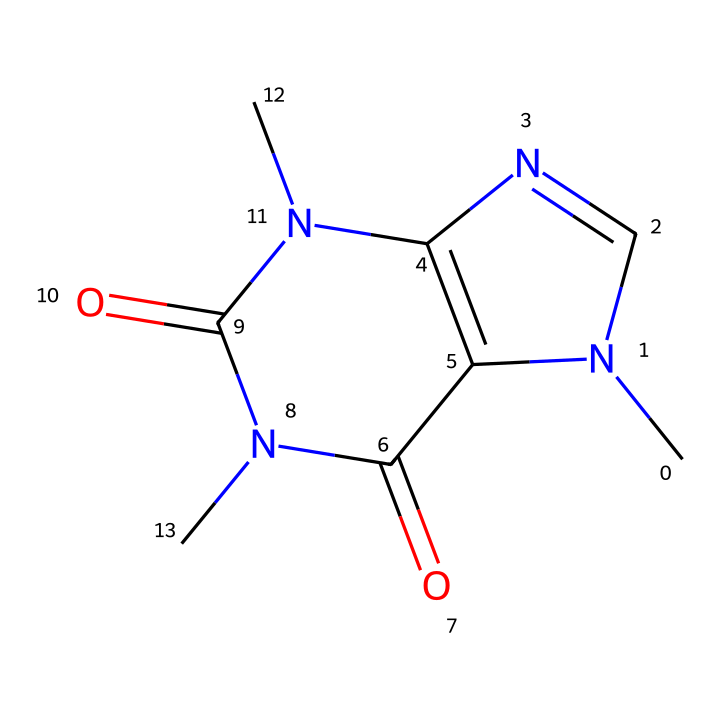how many nitrogen atoms are in the structure? By examining the SMILES representation, we locate the 'N' characters, which stand for nitrogen atoms. The representation features three 'N' atoms within its structure.
Answer: three what is the molecular formula of caffeine? The molecular formula can be deduced by counting the elements represented in the SMILES. The structure indicates the presence of carbon (C), hydrogen (H), nitrogen (N), and oxygen (O), resulting in the formula C8H10N4O2.
Answer: C8H10N4O2 how many rings are present in the molecular structure? Rings are identified by any cyclic structures in the SMILES representation. The given structure contains two fused rings, as indicated by the ring closure symbols (for example, 'N1' and 'N2').
Answer: two what type of drug is caffeine classified as? Caffeine is classified as a stimulant due to its action on the central nervous system, often enhancing alertness and energy levels. This classification is derived from its physiological effects as indicated by its structural characteristics.
Answer: stimulant does caffeine have any functional groups? In the provided SMILES, caffeine contains functional groups, notably amine groups (indicated by nitrogen atoms) and carbonyl groups (represented by 'C=O'). These groups play crucial roles in its chemical behavior and interactions.
Answer: yes what is the primary effect of caffeine on the human body? Caffeine primarily acts as a central nervous system stimulant, increasing alertness and reducing fatigue. This effect is fundamentally tied to its structural properties and the way it interacts with neurotransmitters in the brain.
Answer: alertness is caffeine water-soluble? Caffeine is known to be water-soluble, which pertains to its chemical structure, particularly due to the presence of polar functional groups that interact favorably with water molecules.
Answer: yes 